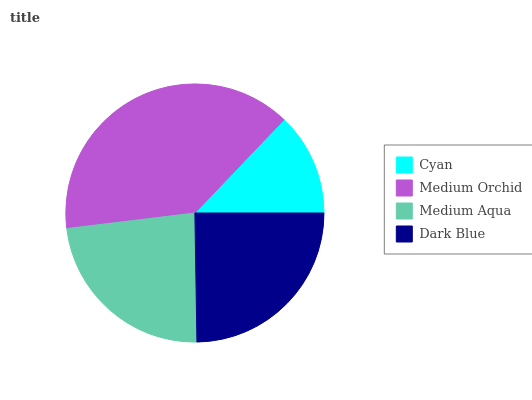Is Cyan the minimum?
Answer yes or no. Yes. Is Medium Orchid the maximum?
Answer yes or no. Yes. Is Medium Aqua the minimum?
Answer yes or no. No. Is Medium Aqua the maximum?
Answer yes or no. No. Is Medium Orchid greater than Medium Aqua?
Answer yes or no. Yes. Is Medium Aqua less than Medium Orchid?
Answer yes or no. Yes. Is Medium Aqua greater than Medium Orchid?
Answer yes or no. No. Is Medium Orchid less than Medium Aqua?
Answer yes or no. No. Is Dark Blue the high median?
Answer yes or no. Yes. Is Medium Aqua the low median?
Answer yes or no. Yes. Is Medium Orchid the high median?
Answer yes or no. No. Is Dark Blue the low median?
Answer yes or no. No. 